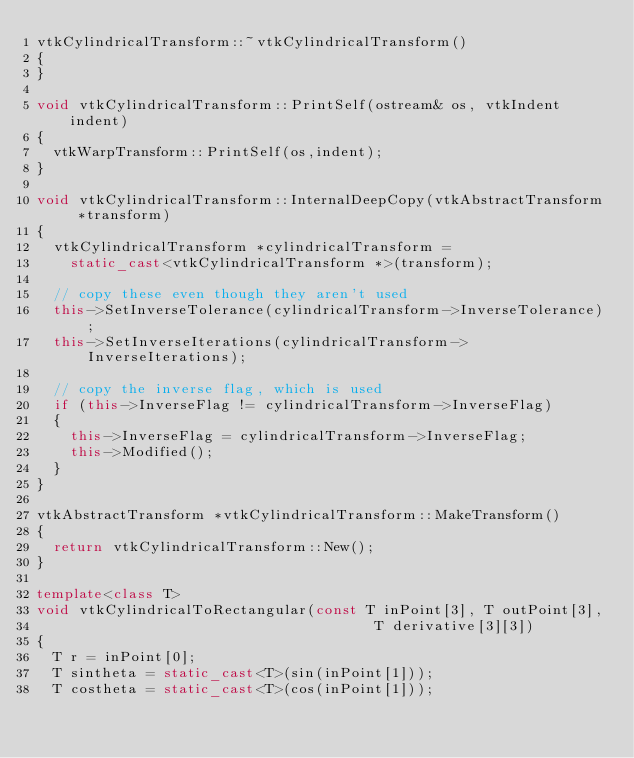Convert code to text. <code><loc_0><loc_0><loc_500><loc_500><_C++_>vtkCylindricalTransform::~vtkCylindricalTransform()
{
}

void vtkCylindricalTransform::PrintSelf(ostream& os, vtkIndent indent)
{
  vtkWarpTransform::PrintSelf(os,indent);
}

void vtkCylindricalTransform::InternalDeepCopy(vtkAbstractTransform *transform)
{
  vtkCylindricalTransform *cylindricalTransform =
    static_cast<vtkCylindricalTransform *>(transform);

  // copy these even though they aren't used
  this->SetInverseTolerance(cylindricalTransform->InverseTolerance);
  this->SetInverseIterations(cylindricalTransform->InverseIterations);

  // copy the inverse flag, which is used
  if (this->InverseFlag != cylindricalTransform->InverseFlag)
  {
    this->InverseFlag = cylindricalTransform->InverseFlag;
    this->Modified();
  }
}

vtkAbstractTransform *vtkCylindricalTransform::MakeTransform()
{
  return vtkCylindricalTransform::New();
}

template<class T>
void vtkCylindricalToRectangular(const T inPoint[3], T outPoint[3],
                                        T derivative[3][3])
{
  T r = inPoint[0];
  T sintheta = static_cast<T>(sin(inPoint[1]));
  T costheta = static_cast<T>(cos(inPoint[1]));</code> 